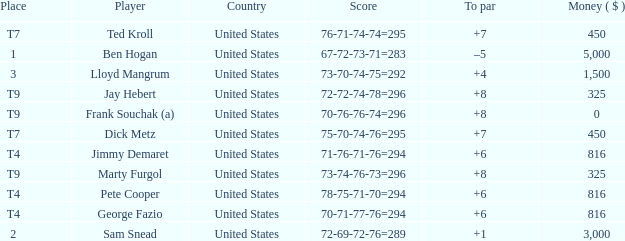Help me parse the entirety of this table. {'header': ['Place', 'Player', 'Country', 'Score', 'To par', 'Money ( $ )'], 'rows': [['T7', 'Ted Kroll', 'United States', '76-71-74-74=295', '+7', '450'], ['1', 'Ben Hogan', 'United States', '67-72-73-71=283', '–5', '5,000'], ['3', 'Lloyd Mangrum', 'United States', '73-70-74-75=292', '+4', '1,500'], ['T9', 'Jay Hebert', 'United States', '72-72-74-78=296', '+8', '325'], ['T9', 'Frank Souchak (a)', 'United States', '70-76-76-74=296', '+8', '0'], ['T7', 'Dick Metz', 'United States', '75-70-74-76=295', '+7', '450'], ['T4', 'Jimmy Demaret', 'United States', '71-76-71-76=294', '+6', '816'], ['T9', 'Marty Furgol', 'United States', '73-74-76-73=296', '+8', '325'], ['T4', 'Pete Cooper', 'United States', '78-75-71-70=294', '+6', '816'], ['T4', 'George Fazio', 'United States', '70-71-77-76=294', '+6', '816'], ['2', 'Sam Snead', 'United States', '72-69-72-76=289', '+1', '3,000']]} How much was paid to the player whose score was 70-71-77-76=294? 816.0. 